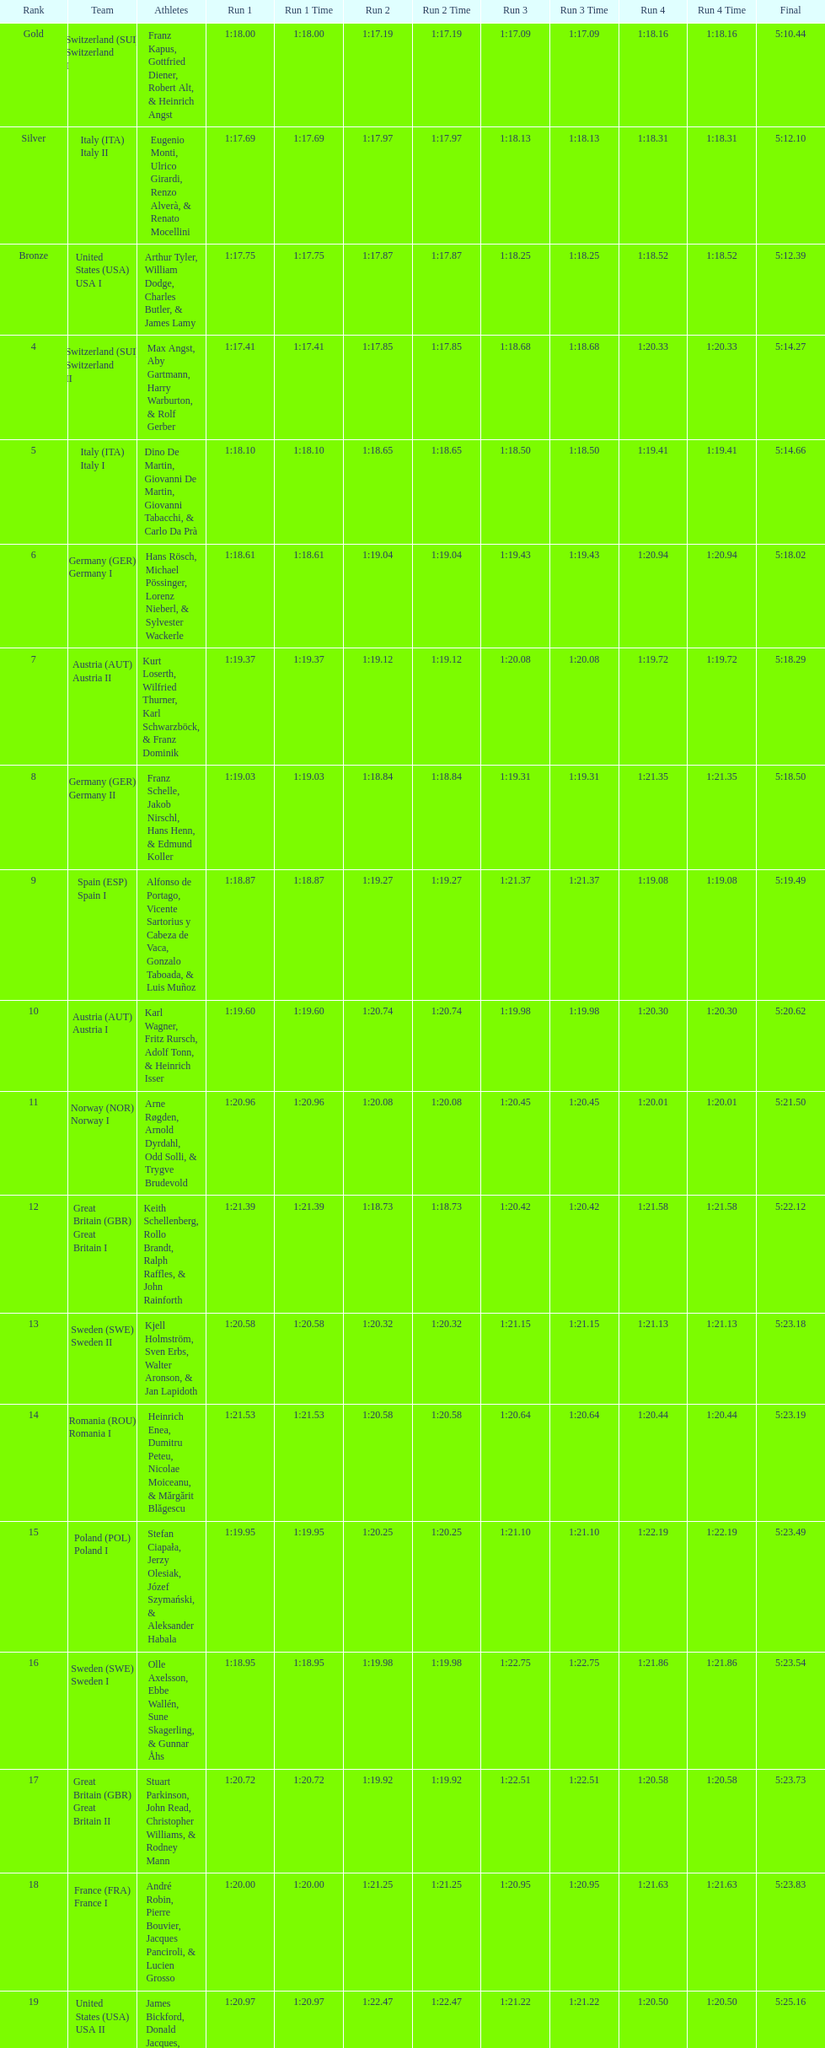What team comes after italy (ita) italy i? Germany I. 